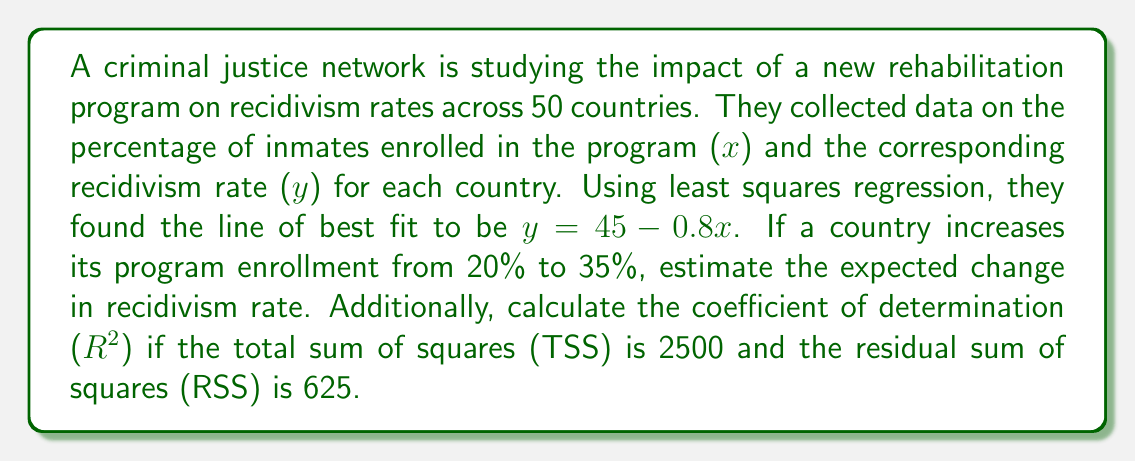Can you answer this question? To solve this problem, we'll follow these steps:

1. Calculate the change in recidivism rate:
   - The line of best fit is $y = 45 - 0.8x$
   - For x = 20%: $y_1 = 45 - 0.8(20) = 29$
   - For x = 35%: $y_2 = 45 - 0.8(35) = 17$
   - Change in recidivism rate = $y_2 - y_1 = 17 - 29 = -12$

2. Calculate the coefficient of determination ($R^2$):
   - $R^2 = 1 - \frac{RSS}{TSS}$
   - Given: TSS = 2500, RSS = 625
   - $R^2 = 1 - \frac{625}{2500} = 1 - 0.25 = 0.75$

The negative change in recidivism rate indicates a decrease, which is expected as program enrollment increases. The $R^2$ value of 0.75 suggests that 75% of the variance in recidivism rates can be explained by the variation in program enrollment.
Answer: The expected change in recidivism rate is -12 percentage points, and the coefficient of determination ($R^2$) is 0.75. 